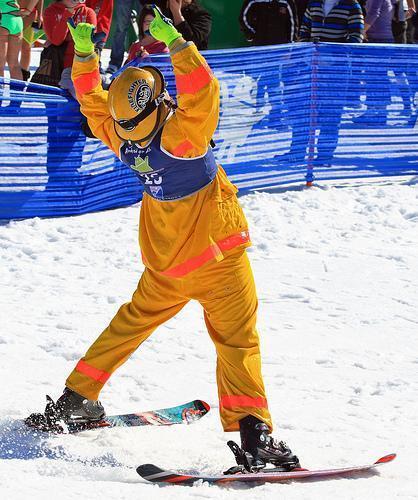How many people on skiis?
Give a very brief answer. 1. 